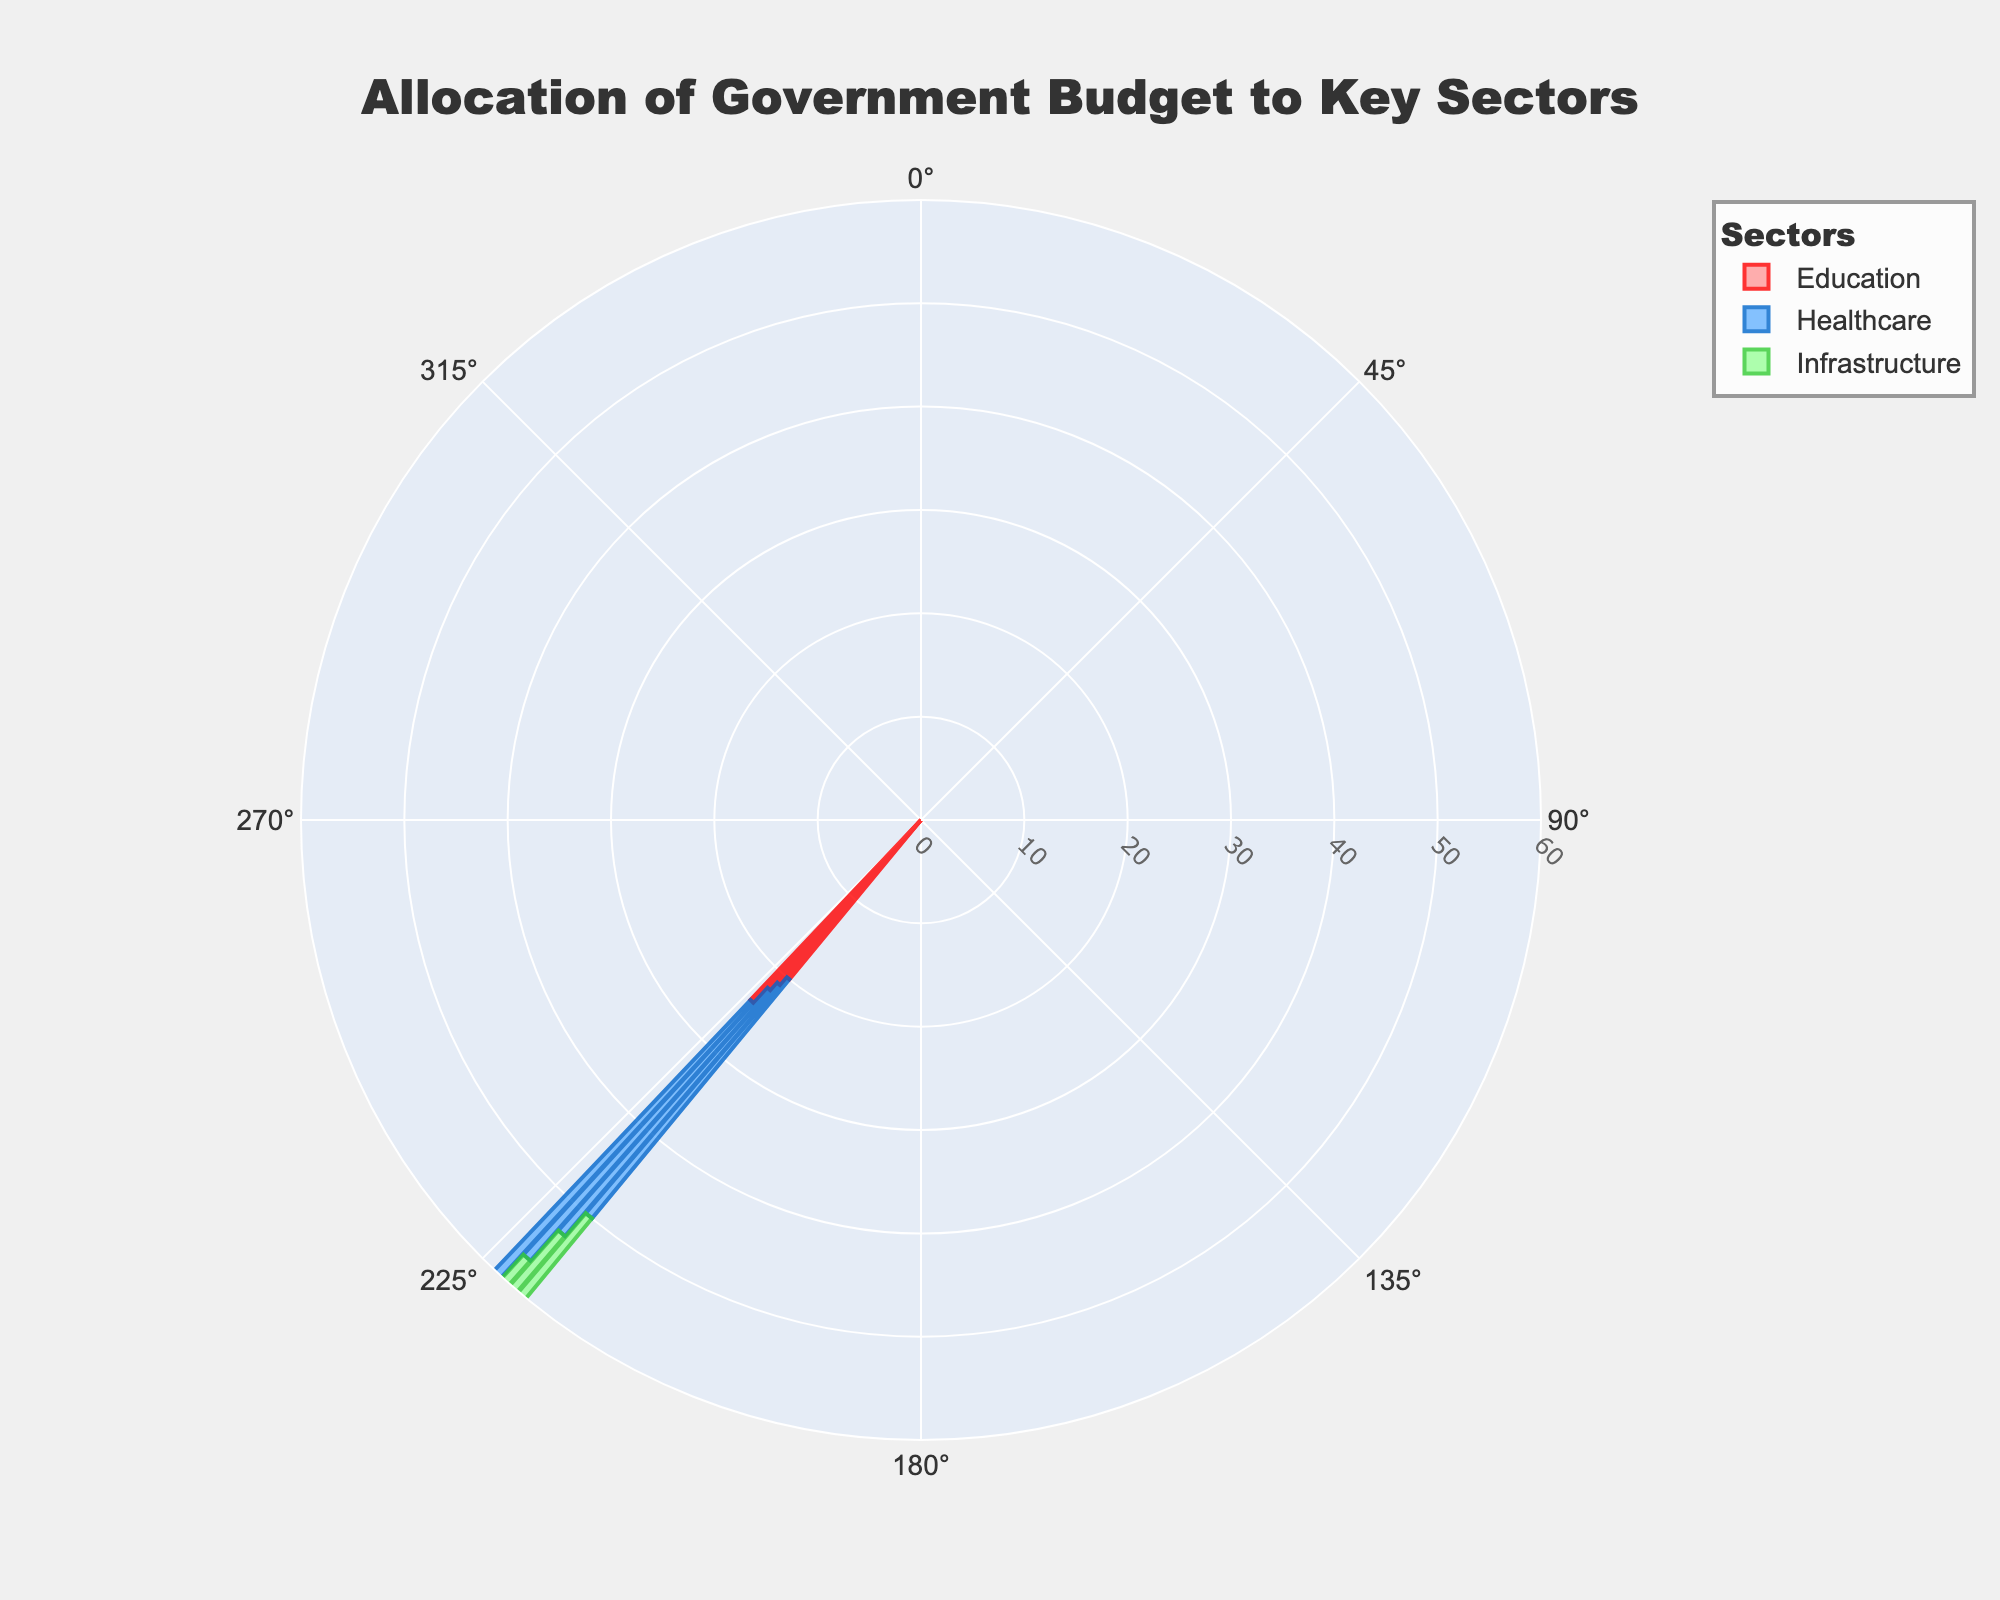What is the title of the chart? The title at the top of the chart reads "Allocation of Government Budget to Key Sectors".
Answer: Allocation of Government Budget to Key Sectors Which sector has the highest budget allocation in 2023? In 2023, the sector with the highest radius value is Infrastructure, depicted in green.
Answer: Infrastructure How has the budget allocation to Education changed from 2020 to 2023? By observing the heights of the bars for Education from 2020 to 2023, which gradually increase from 20 to 24, one can see the increment.
Answer: Increased Compare the budget allocations for Healthcare between 2021 and 2023. Which year had a higher allocation? By looking at the radius values of the blue Healthcare bars, which are higher in 2023 (37) than in 2021 (32), it's clear 2023 had a higher allocation.
Answer: 2023 What is the difference in budget allocation between Education and Healthcare in 2022? The radius for Education is 22 and for Healthcare is 35 in 2022. The difference is 35 - 22 = 13.
Answer: 13 Which sector shows a decreasing trend from 2020 to 2023? By observing the overall trend across the years, the green Infrastructure bars consistently decrease, unlike the others.
Answer: Infrastructure How much did the budget allocation for Infrastructure decrease from 2020 to 2023? The radius for Infrastructure was 50 in 2020 and 39 in 2023, resulting in a decrease of 50 - 39 = 11.
Answer: 11 How many sectors are presented in the chart? The legend and different color bars indicate there are three sectors: Education, Healthcare, and Infrastructure.
Answer: Three What is the average budget allocation for Healthcare from 2020 to 2023? Add the radius values for Healthcare from 2020 to 2023: 30 + 32 + 35 + 37 = 134, and divide by 4: 134 / 4 = 33.5.
Answer: 33.5 Which year shows the highest total allocation among all three sectors? By summing the radius values for each year (2020: 20+30+50=100, 2021: 21+32+47=100, 2022: 22+35+43=100, 2023: 24+37+39=100), the total allocation is the same (100) for all years.
Answer: All years 